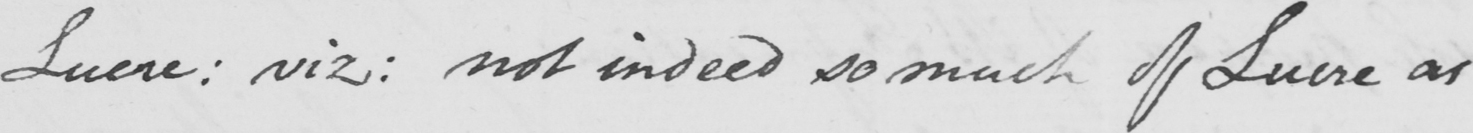What is written in this line of handwriting? Lucre :  viz :  not indeed so much of Luere as 